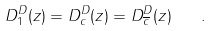Convert formula to latex. <formula><loc_0><loc_0><loc_500><loc_500>D _ { 1 } ^ { D } ( z ) = D _ { c } ^ { D } ( z ) = D _ { \overline { c } } ^ { D } ( z ) \quad .</formula> 